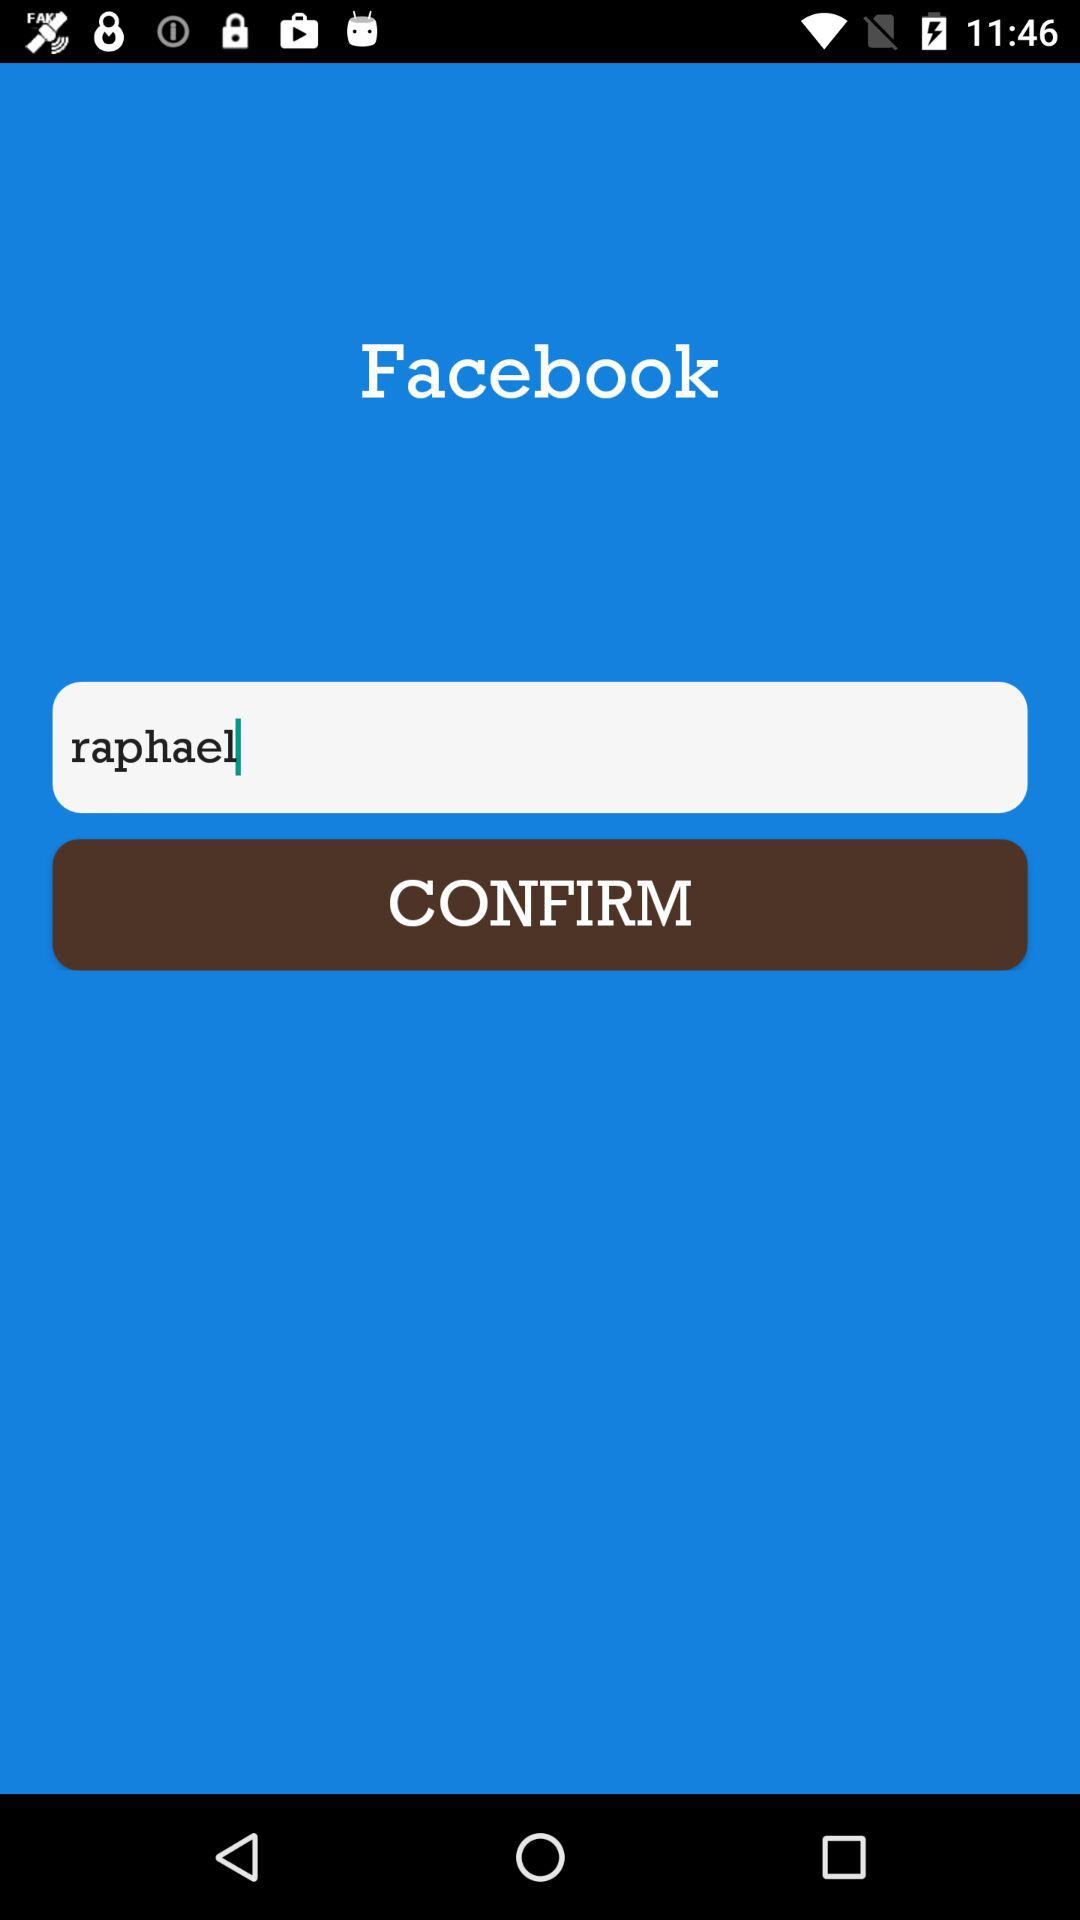What is the name? The name is Raphael. 